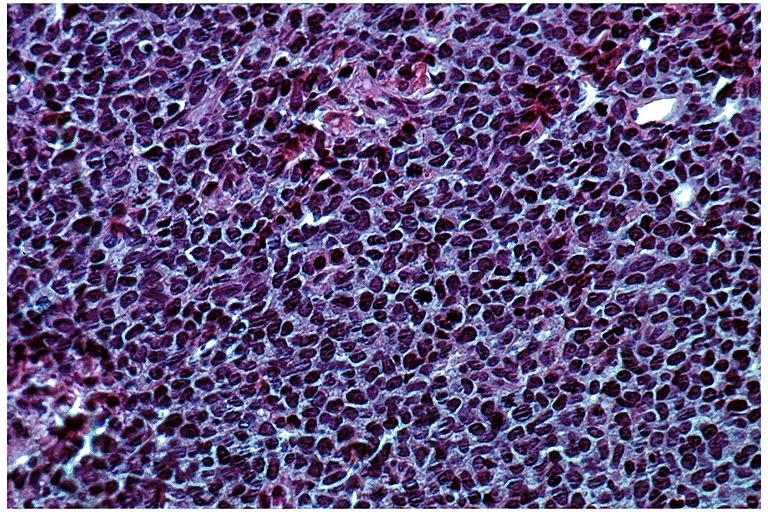what does this image show?
Answer the question using a single word or phrase. Lymphoma 